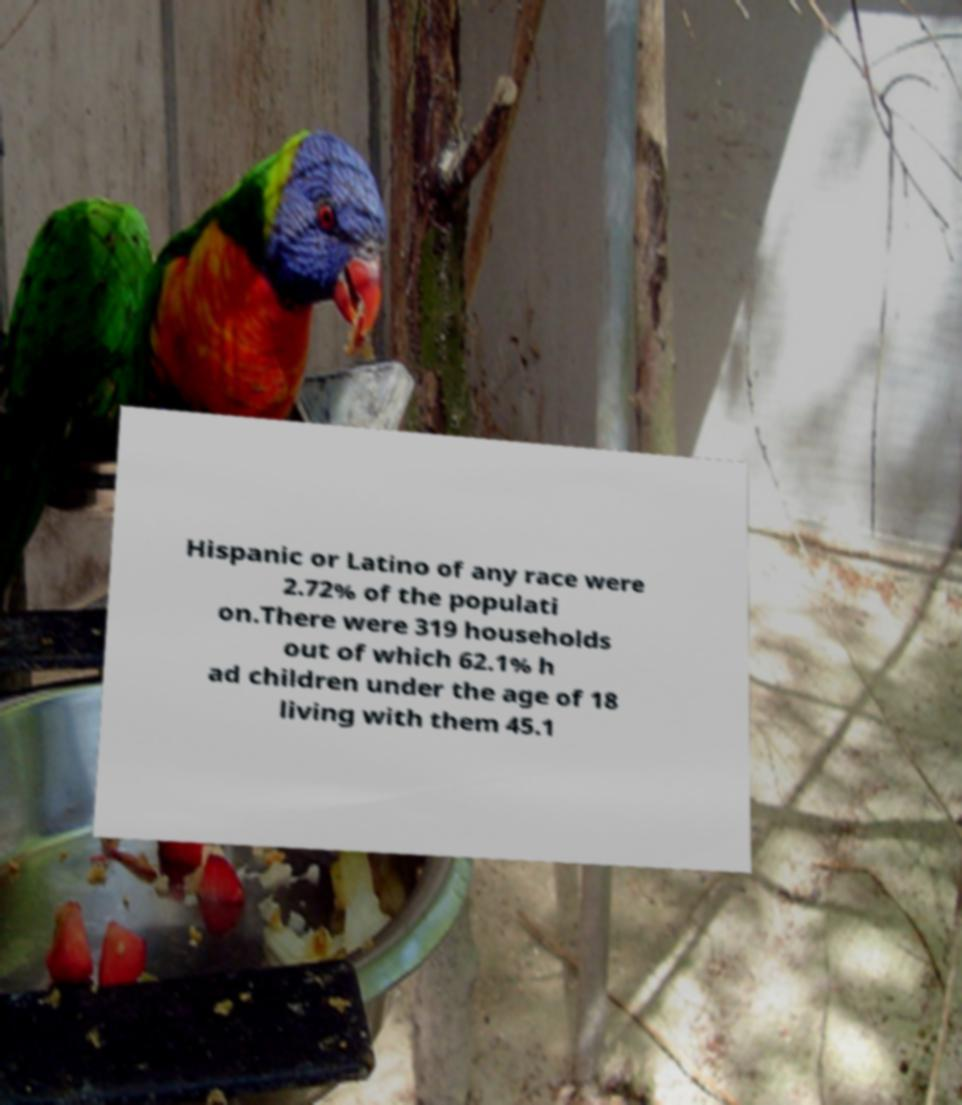What messages or text are displayed in this image? I need them in a readable, typed format. Hispanic or Latino of any race were 2.72% of the populati on.There were 319 households out of which 62.1% h ad children under the age of 18 living with them 45.1 